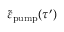<formula> <loc_0><loc_0><loc_500><loc_500>\tilde { \varepsilon } _ { p u m p } ( \tau ^ { \prime } )</formula> 